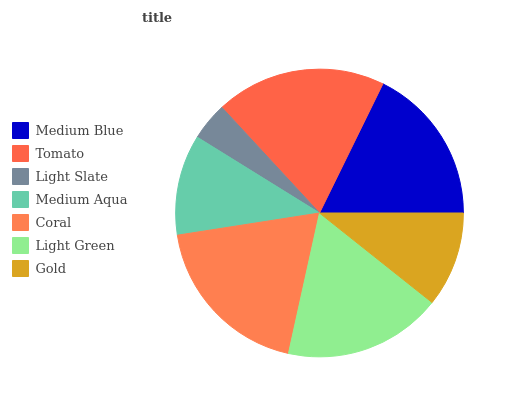Is Light Slate the minimum?
Answer yes or no. Yes. Is Tomato the maximum?
Answer yes or no. Yes. Is Tomato the minimum?
Answer yes or no. No. Is Light Slate the maximum?
Answer yes or no. No. Is Tomato greater than Light Slate?
Answer yes or no. Yes. Is Light Slate less than Tomato?
Answer yes or no. Yes. Is Light Slate greater than Tomato?
Answer yes or no. No. Is Tomato less than Light Slate?
Answer yes or no. No. Is Medium Blue the high median?
Answer yes or no. Yes. Is Medium Blue the low median?
Answer yes or no. Yes. Is Light Slate the high median?
Answer yes or no. No. Is Gold the low median?
Answer yes or no. No. 